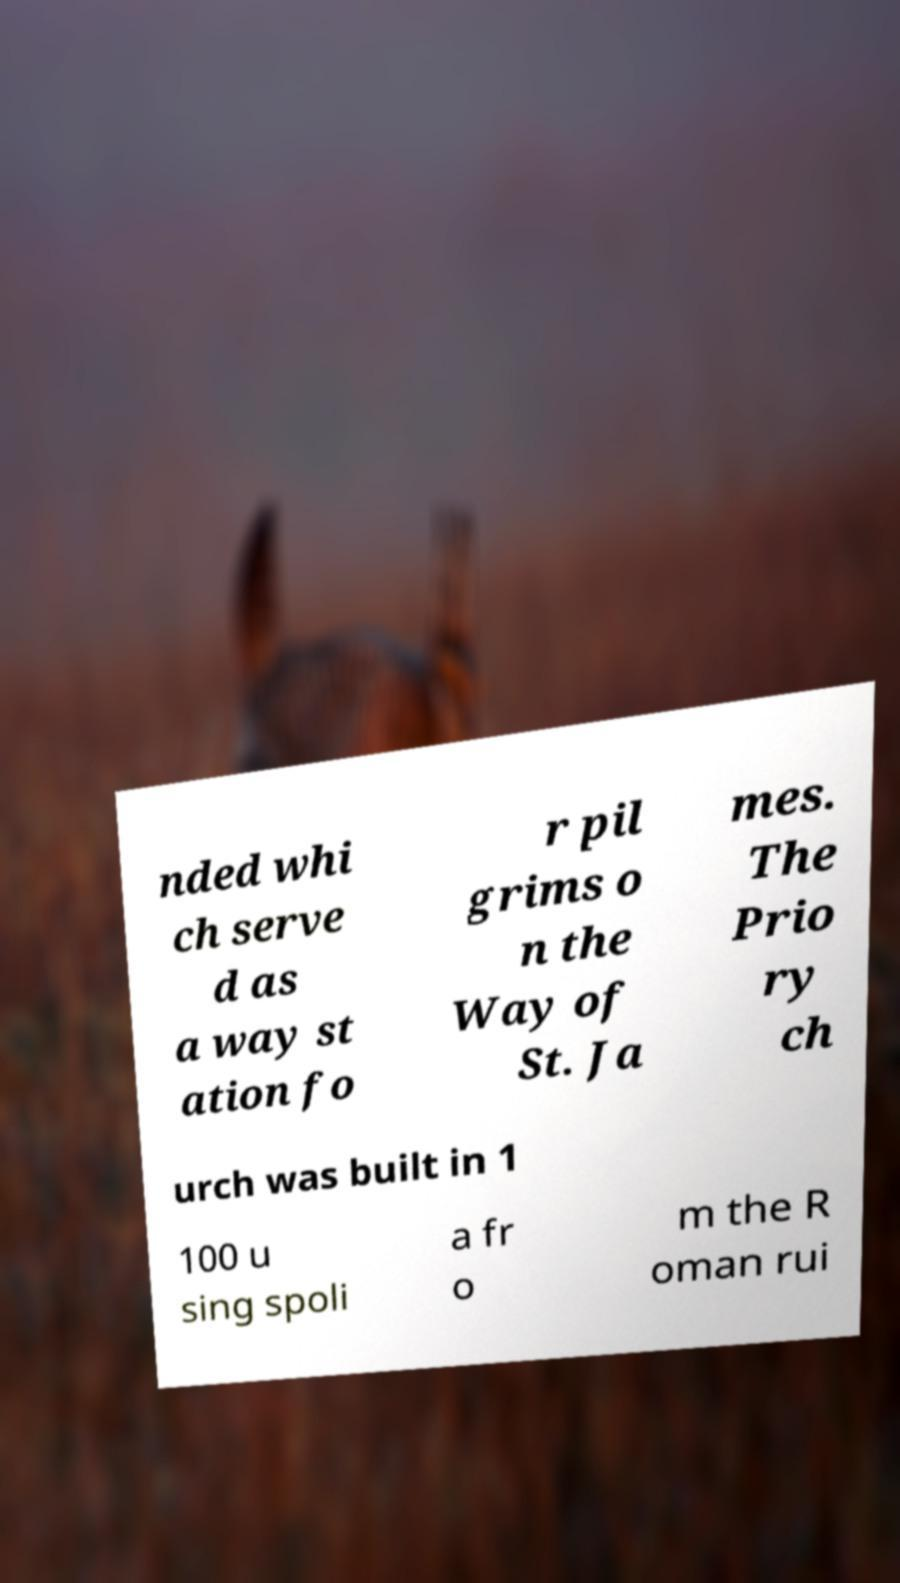Could you assist in decoding the text presented in this image and type it out clearly? nded whi ch serve d as a way st ation fo r pil grims o n the Way of St. Ja mes. The Prio ry ch urch was built in 1 100 u sing spoli a fr o m the R oman rui 